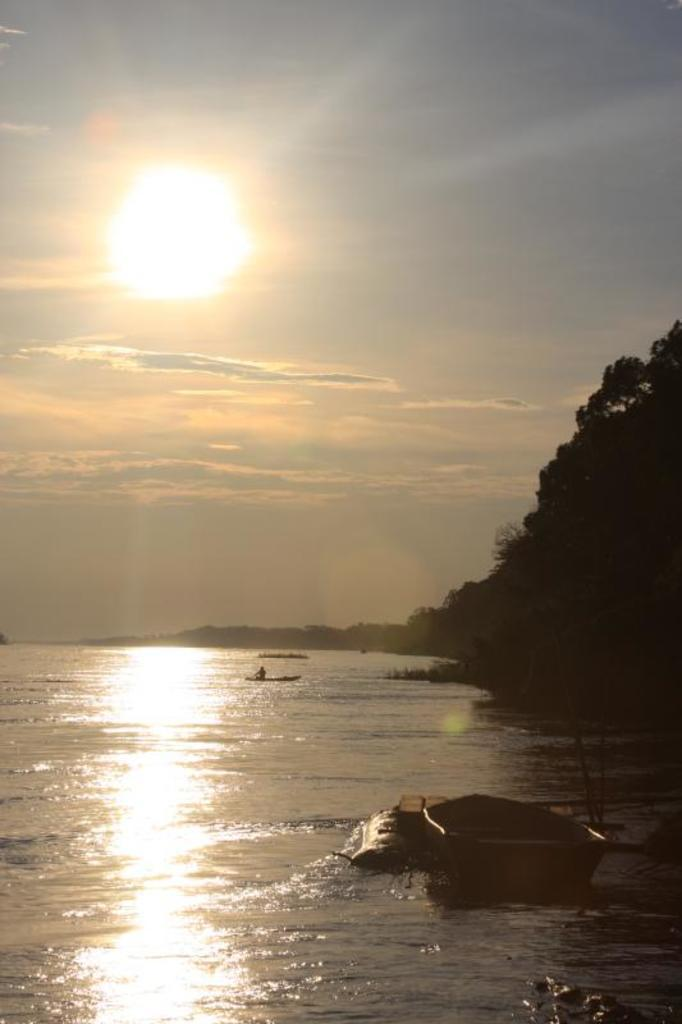What type of vehicles can be seen in the water in the image? There are boats in the water in the image. What type of vegetation is visible in the image? There are trees visible in the image. What part of the natural environment is visible in the background of the image? The sky is visible in the background of the image. What can be seen in the sky in the image? Clouds are present in the sky in the image. What type of discussion is taking place between the father and the hand in the image? There is no discussion, father, or hand present in the image. 